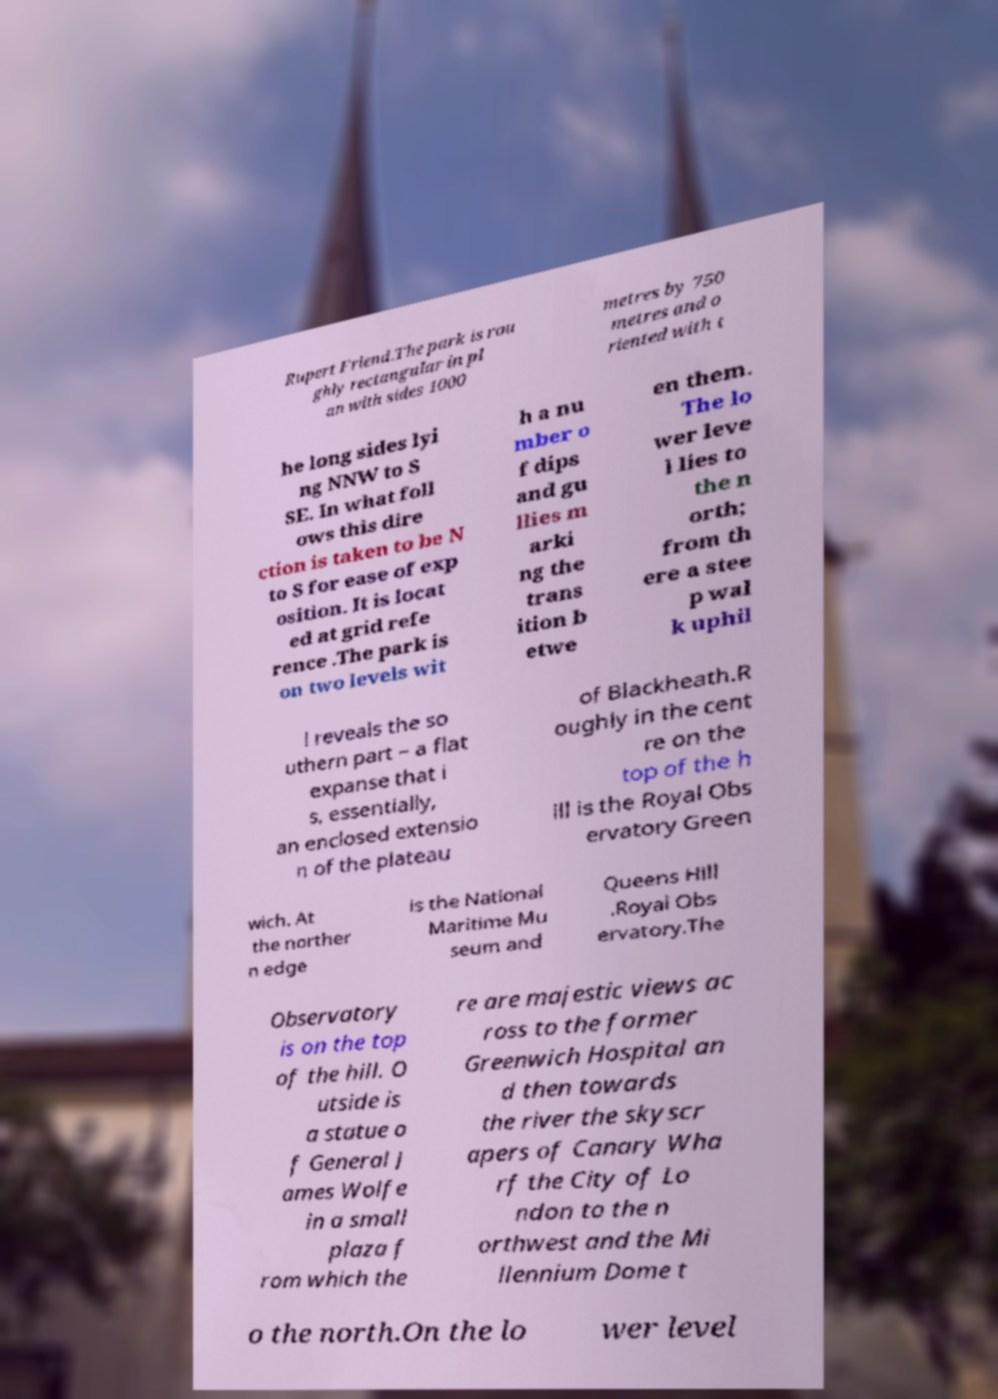Please identify and transcribe the text found in this image. Rupert Friend.The park is rou ghly rectangular in pl an with sides 1000 metres by 750 metres and o riented with t he long sides lyi ng NNW to S SE. In what foll ows this dire ction is taken to be N to S for ease of exp osition. It is locat ed at grid refe rence .The park is on two levels wit h a nu mber o f dips and gu llies m arki ng the trans ition b etwe en them. The lo wer leve l lies to the n orth; from th ere a stee p wal k uphil l reveals the so uthern part – a flat expanse that i s, essentially, an enclosed extensio n of the plateau of Blackheath.R oughly in the cent re on the top of the h ill is the Royal Obs ervatory Green wich. At the norther n edge is the National Maritime Mu seum and Queens Hill .Royal Obs ervatory.The Observatory is on the top of the hill. O utside is a statue o f General J ames Wolfe in a small plaza f rom which the re are majestic views ac ross to the former Greenwich Hospital an d then towards the river the skyscr apers of Canary Wha rf the City of Lo ndon to the n orthwest and the Mi llennium Dome t o the north.On the lo wer level 